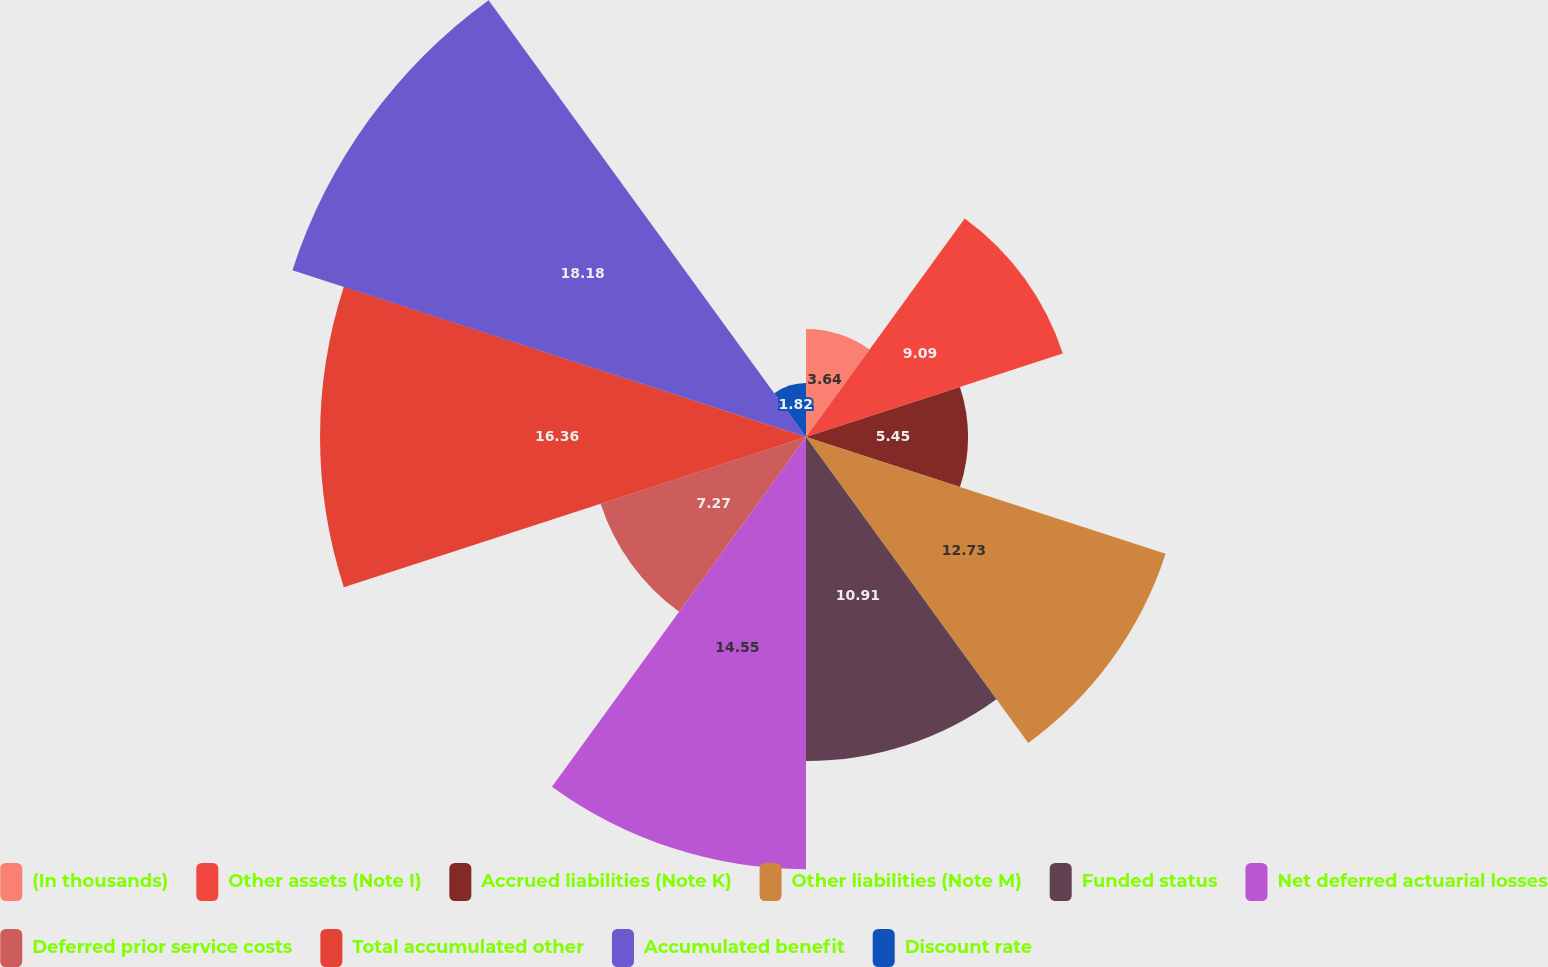Convert chart. <chart><loc_0><loc_0><loc_500><loc_500><pie_chart><fcel>(In thousands)<fcel>Other assets (Note I)<fcel>Accrued liabilities (Note K)<fcel>Other liabilities (Note M)<fcel>Funded status<fcel>Net deferred actuarial losses<fcel>Deferred prior service costs<fcel>Total accumulated other<fcel>Accumulated benefit<fcel>Discount rate<nl><fcel>3.64%<fcel>9.09%<fcel>5.45%<fcel>12.73%<fcel>10.91%<fcel>14.55%<fcel>7.27%<fcel>16.36%<fcel>18.18%<fcel>1.82%<nl></chart> 